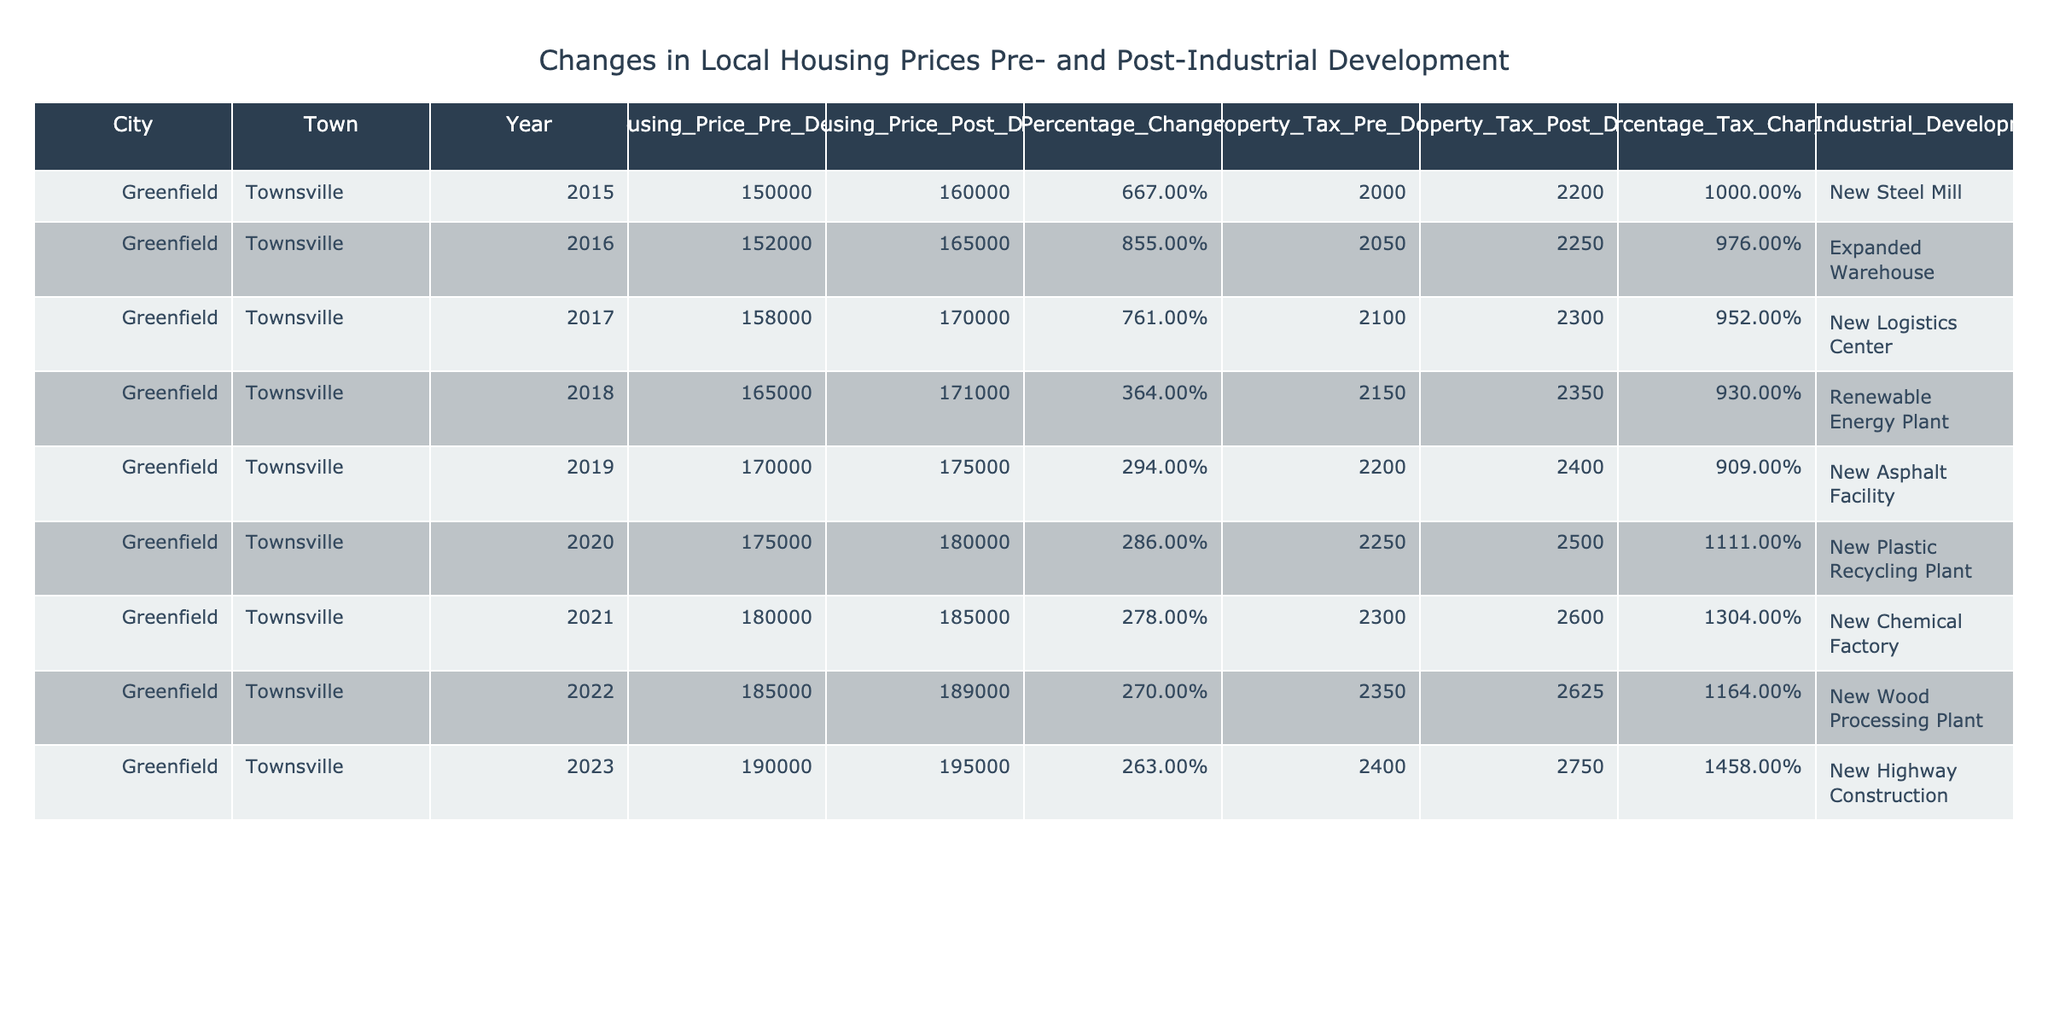What was the median housing price in Townsville in 2020? According to the table, the median housing price in Townsville for the year 2020 is listed under the column "Median_Housing_Price_Post_Development," which shows the value is 180,000.
Answer: 180000 What was the percentage change in housing prices from 2015 to 2016? The percentage change can be calculated by taking the median housing prices for 2015 and 2016. The values are 160,000 (2016) and 150,000 (2015). The percentage change is ((165000 - 152000) / 152000) * 100 = 8.55%.
Answer: 8.55% How much did the average property tax increase from 2018 to 2019? The average property tax values for 2018 and 2019 are 2,350 and 2,400, respectively. The difference is 2,400 - 2,350 = 50.
Answer: 50 Was there any year when the percentage change in housing prices was greater than 8%? From the table, in the reports for 2015 and 2016, the percentage change was 8.55%, which is greater than 8%.
Answer: Yes What was the average percentage change in housing prices across all years reported? To find the average percentage change, sum all percentage change values: (6.67 + 8.55 + 7.61 + 3.64 + 2.94 + 2.86 + 2.78 + 2.70 + 2.63) = 38.78. Since there are 9 years, the average is 38.78 / 9 = 4.31%.
Answer: 4.31% Which year saw the greatest increase in average property tax? From the table, comparing the average property taxes across all years shows that the greatest increase occurred from 2020 to 2021, with an increase from 2,500 to 2,600, which is 100.
Answer: 100 In which year was the percentage tax change over 14%? The table indicates that in 2023, the percentage tax change reached 14.58%, which is the only instance over 14%.
Answer: 2023 What is the relationship between new industrial developments and housing price changes? By observing the table, we note that with each new industrial development, there has been a consistent uptick, albeit varying percentage changes in housing prices, especially in the initial years where increases were higher compared to later years. Overall, a trend shows a consistent increase in housing prices alongside new developments.
Answer: Positive correlation 